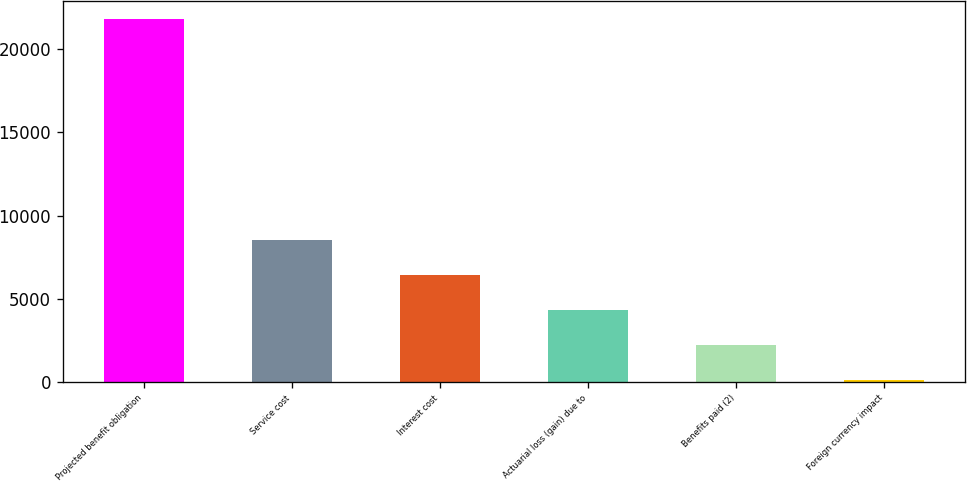Convert chart. <chart><loc_0><loc_0><loc_500><loc_500><bar_chart><fcel>Projected benefit obligation<fcel>Service cost<fcel>Interest cost<fcel>Actuarial loss (gain) due to<fcel>Benefits paid (2)<fcel>Foreign currency impact<nl><fcel>21832.8<fcel>8543.2<fcel>6440.4<fcel>4337.6<fcel>2234.8<fcel>132<nl></chart> 